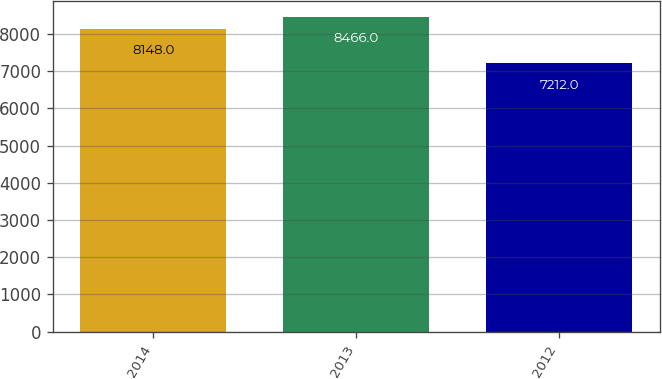Convert chart. <chart><loc_0><loc_0><loc_500><loc_500><bar_chart><fcel>2014<fcel>2013<fcel>2012<nl><fcel>8148<fcel>8466<fcel>7212<nl></chart> 